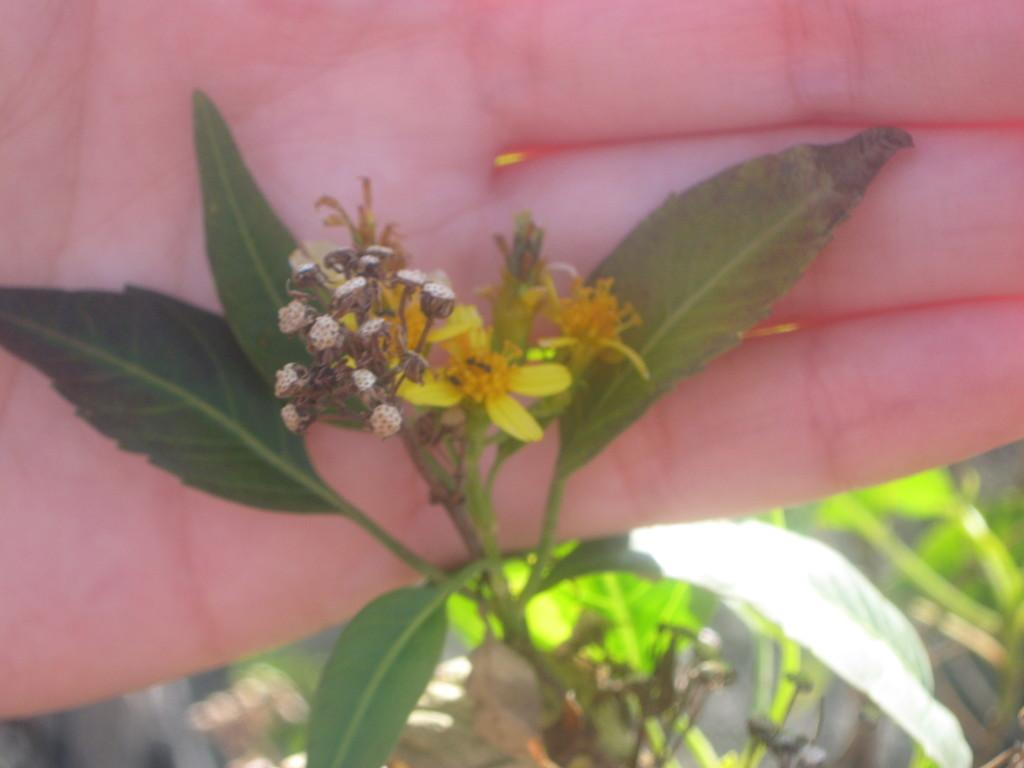What part of a person's body is visible in the image? There is a person's hand in the image. What type of living organism is present in the image? There is a plant in the image. What stage of growth are the plant's buds in? The plant has some buds. What type of laborer can be seen working at the airport in the image? There is no laborer or airport present in the image. What is the plant's tendency to grow in the image? The provided facts do not mention any information about the plant's tendency to grow. 